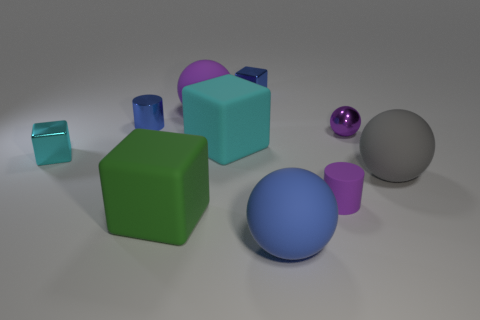Is there a pattern in the arrangement of these objects? The objects seem to be arranged randomly, with varying distances between them. There is no discernible pattern to their placement on the surface. 